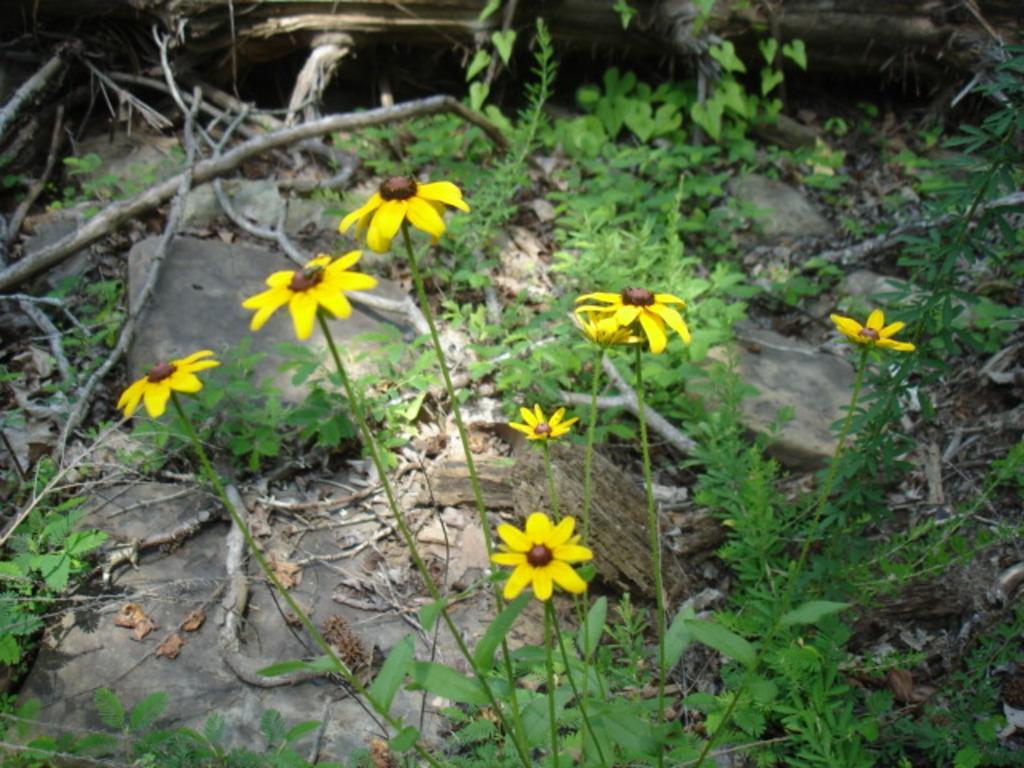Can you describe this image briefly? This image consists of plants. There are flowers in this image. They are in yellow color. 